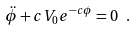Convert formula to latex. <formula><loc_0><loc_0><loc_500><loc_500>\ddot { \phi } + c V _ { 0 } e ^ { - c \phi } = 0 \ .</formula> 